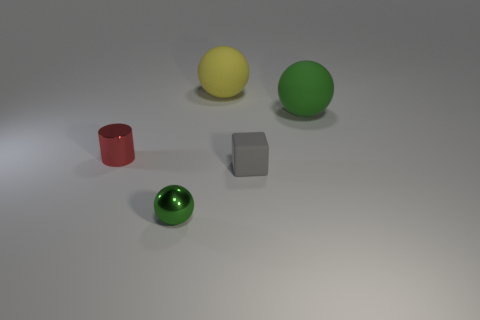How many things are either small blocks or tiny objects behind the small green metal sphere?
Ensure brevity in your answer.  2. Is there anything else that has the same material as the yellow object?
Your answer should be compact. Yes. There is a matte thing that is the same color as the tiny sphere; what shape is it?
Provide a succinct answer. Sphere. What is the material of the tiny gray cube?
Ensure brevity in your answer.  Rubber. Does the small gray thing have the same material as the yellow sphere?
Offer a terse response. Yes. How many matte objects are either small gray cubes or green spheres?
Offer a very short reply. 2. What is the shape of the green object on the left side of the green matte thing?
Ensure brevity in your answer.  Sphere. The yellow thing that is the same material as the tiny block is what size?
Give a very brief answer. Large. There is a object that is in front of the red metal object and right of the tiny metal ball; what shape is it?
Ensure brevity in your answer.  Cube. Do the ball that is in front of the small red shiny cylinder and the cylinder have the same color?
Offer a very short reply. No. 